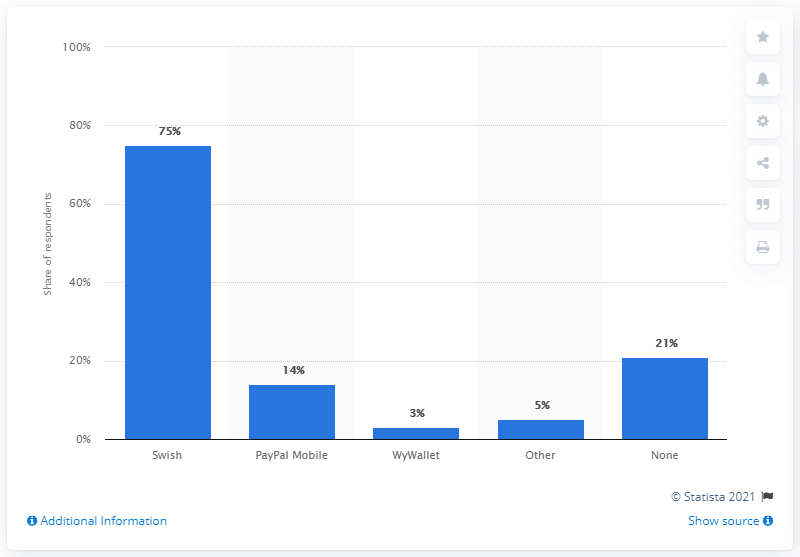Highlight a few significant elements in this photo. The most popular mobile payment service in Sweden in 2017 was Swish. In 2019, there were approximately 75 Swish customers in Sweden. In 2017, 75% of respondents reported using Swish. 